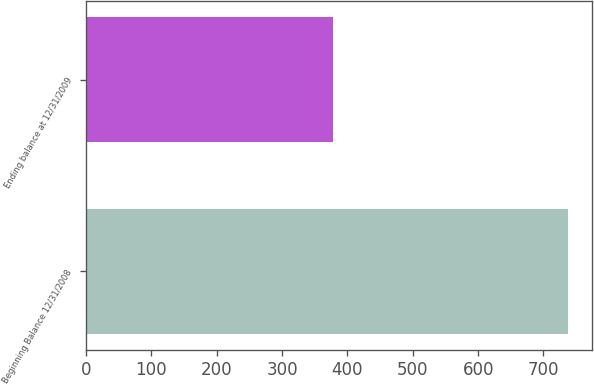<chart> <loc_0><loc_0><loc_500><loc_500><bar_chart><fcel>Beginning Balance 12/31/2008<fcel>Ending balance at 12/31/2009<nl><fcel>737<fcel>378<nl></chart> 